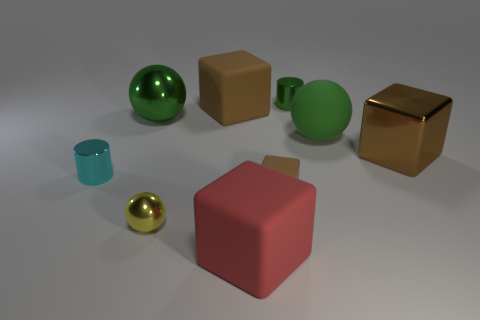Subtract all big cubes. How many cubes are left? 1 Add 1 big matte cubes. How many objects exist? 10 Subtract all green cylinders. How many brown blocks are left? 3 Subtract all red blocks. How many blocks are left? 3 Subtract all spheres. How many objects are left? 6 Subtract all cyan blocks. Subtract all cyan spheres. How many blocks are left? 4 Add 3 big red blocks. How many big red blocks are left? 4 Add 2 small red rubber cylinders. How many small red rubber cylinders exist? 2 Subtract 1 yellow spheres. How many objects are left? 8 Subtract all tiny cyan balls. Subtract all rubber objects. How many objects are left? 5 